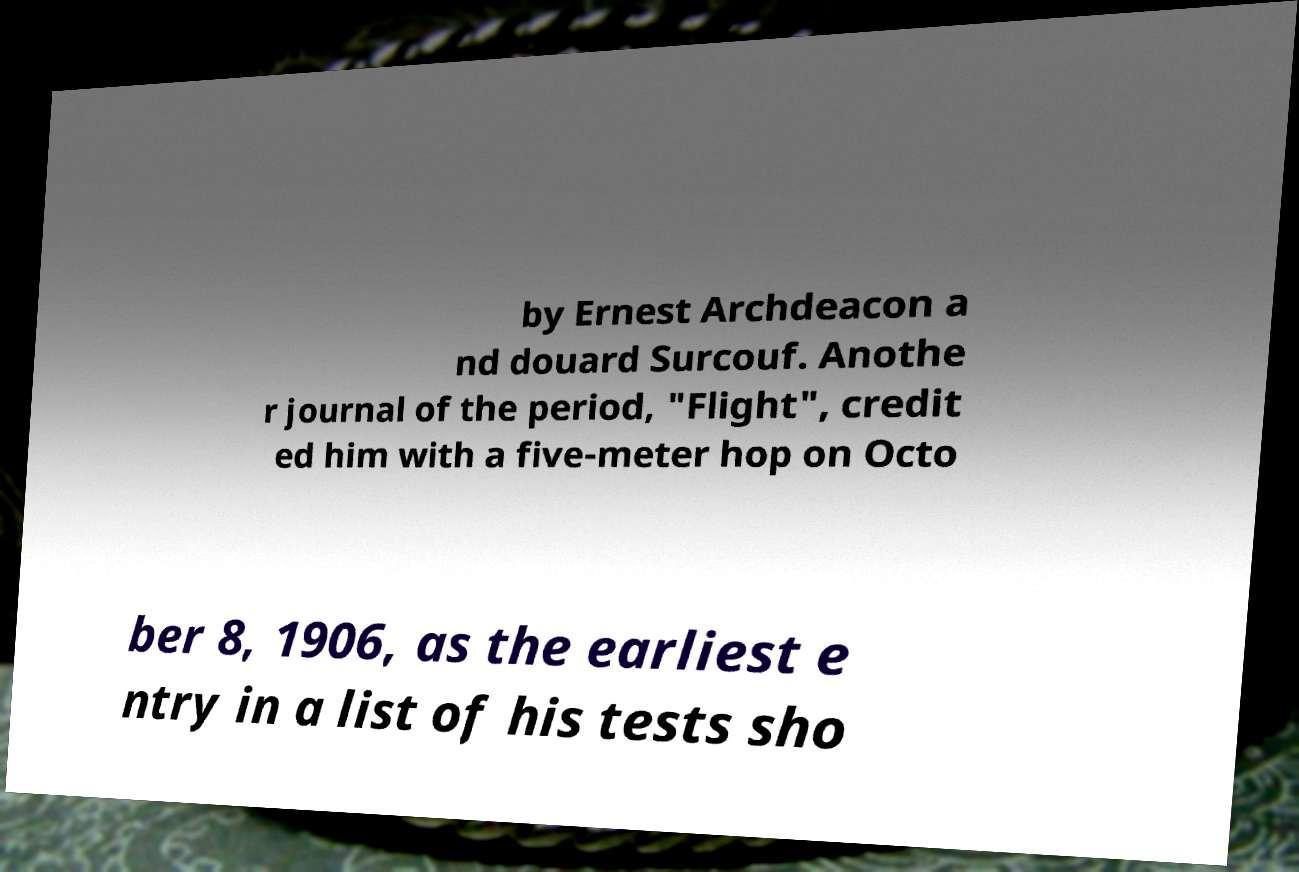There's text embedded in this image that I need extracted. Can you transcribe it verbatim? by Ernest Archdeacon a nd douard Surcouf. Anothe r journal of the period, "Flight", credit ed him with a five-meter hop on Octo ber 8, 1906, as the earliest e ntry in a list of his tests sho 